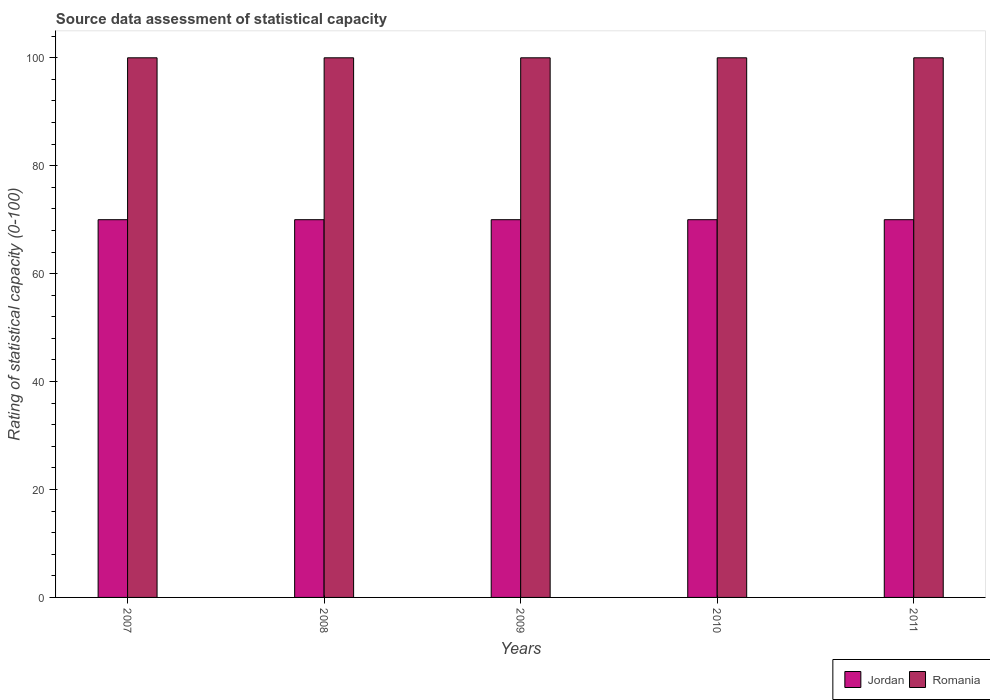How many groups of bars are there?
Make the answer very short. 5. What is the label of the 2nd group of bars from the left?
Keep it short and to the point. 2008. In how many cases, is the number of bars for a given year not equal to the number of legend labels?
Keep it short and to the point. 0. What is the rating of statistical capacity in Jordan in 2008?
Offer a very short reply. 70. Across all years, what is the maximum rating of statistical capacity in Romania?
Provide a succinct answer. 100. Across all years, what is the minimum rating of statistical capacity in Jordan?
Your answer should be compact. 70. In which year was the rating of statistical capacity in Romania maximum?
Provide a succinct answer. 2007. In which year was the rating of statistical capacity in Jordan minimum?
Provide a short and direct response. 2007. What is the total rating of statistical capacity in Jordan in the graph?
Make the answer very short. 350. What is the difference between the rating of statistical capacity in Jordan in 2011 and the rating of statistical capacity in Romania in 2009?
Keep it short and to the point. -30. In the year 2009, what is the difference between the rating of statistical capacity in Jordan and rating of statistical capacity in Romania?
Your answer should be compact. -30. What is the ratio of the rating of statistical capacity in Romania in 2008 to that in 2009?
Make the answer very short. 1. Is the difference between the rating of statistical capacity in Jordan in 2008 and 2010 greater than the difference between the rating of statistical capacity in Romania in 2008 and 2010?
Ensure brevity in your answer.  No. What does the 1st bar from the left in 2007 represents?
Keep it short and to the point. Jordan. What does the 2nd bar from the right in 2009 represents?
Keep it short and to the point. Jordan. How many bars are there?
Provide a succinct answer. 10. How many years are there in the graph?
Provide a succinct answer. 5. What is the difference between two consecutive major ticks on the Y-axis?
Give a very brief answer. 20. Are the values on the major ticks of Y-axis written in scientific E-notation?
Make the answer very short. No. Does the graph contain any zero values?
Ensure brevity in your answer.  No. Does the graph contain grids?
Provide a short and direct response. No. Where does the legend appear in the graph?
Keep it short and to the point. Bottom right. What is the title of the graph?
Your answer should be compact. Source data assessment of statistical capacity. What is the label or title of the X-axis?
Give a very brief answer. Years. What is the label or title of the Y-axis?
Provide a succinct answer. Rating of statistical capacity (0-100). What is the Rating of statistical capacity (0-100) of Romania in 2007?
Make the answer very short. 100. What is the Rating of statistical capacity (0-100) of Jordan in 2008?
Keep it short and to the point. 70. What is the Rating of statistical capacity (0-100) of Jordan in 2009?
Make the answer very short. 70. What is the Rating of statistical capacity (0-100) of Romania in 2011?
Make the answer very short. 100. Across all years, what is the maximum Rating of statistical capacity (0-100) in Jordan?
Provide a succinct answer. 70. Across all years, what is the maximum Rating of statistical capacity (0-100) in Romania?
Provide a short and direct response. 100. What is the total Rating of statistical capacity (0-100) of Jordan in the graph?
Offer a terse response. 350. What is the total Rating of statistical capacity (0-100) of Romania in the graph?
Provide a succinct answer. 500. What is the difference between the Rating of statistical capacity (0-100) of Romania in 2007 and that in 2009?
Offer a terse response. 0. What is the difference between the Rating of statistical capacity (0-100) of Jordan in 2007 and that in 2010?
Provide a succinct answer. 0. What is the difference between the Rating of statistical capacity (0-100) in Jordan in 2007 and that in 2011?
Your answer should be very brief. 0. What is the difference between the Rating of statistical capacity (0-100) of Jordan in 2008 and that in 2009?
Offer a terse response. 0. What is the difference between the Rating of statistical capacity (0-100) in Romania in 2008 and that in 2009?
Provide a succinct answer. 0. What is the difference between the Rating of statistical capacity (0-100) in Romania in 2008 and that in 2010?
Provide a short and direct response. 0. What is the difference between the Rating of statistical capacity (0-100) of Romania in 2008 and that in 2011?
Keep it short and to the point. 0. What is the difference between the Rating of statistical capacity (0-100) of Jordan in 2009 and that in 2010?
Your response must be concise. 0. What is the difference between the Rating of statistical capacity (0-100) of Romania in 2009 and that in 2010?
Your response must be concise. 0. What is the difference between the Rating of statistical capacity (0-100) in Jordan in 2009 and that in 2011?
Provide a short and direct response. 0. What is the difference between the Rating of statistical capacity (0-100) of Jordan in 2010 and that in 2011?
Give a very brief answer. 0. What is the difference between the Rating of statistical capacity (0-100) of Romania in 2010 and that in 2011?
Offer a terse response. 0. What is the difference between the Rating of statistical capacity (0-100) in Jordan in 2007 and the Rating of statistical capacity (0-100) in Romania in 2010?
Your answer should be compact. -30. What is the difference between the Rating of statistical capacity (0-100) of Jordan in 2008 and the Rating of statistical capacity (0-100) of Romania in 2009?
Make the answer very short. -30. What is the average Rating of statistical capacity (0-100) of Romania per year?
Provide a succinct answer. 100. In the year 2008, what is the difference between the Rating of statistical capacity (0-100) of Jordan and Rating of statistical capacity (0-100) of Romania?
Make the answer very short. -30. In the year 2010, what is the difference between the Rating of statistical capacity (0-100) in Jordan and Rating of statistical capacity (0-100) in Romania?
Ensure brevity in your answer.  -30. In the year 2011, what is the difference between the Rating of statistical capacity (0-100) in Jordan and Rating of statistical capacity (0-100) in Romania?
Give a very brief answer. -30. What is the ratio of the Rating of statistical capacity (0-100) of Romania in 2007 to that in 2008?
Offer a terse response. 1. What is the ratio of the Rating of statistical capacity (0-100) in Jordan in 2007 to that in 2009?
Make the answer very short. 1. What is the ratio of the Rating of statistical capacity (0-100) of Romania in 2007 to that in 2009?
Offer a terse response. 1. What is the ratio of the Rating of statistical capacity (0-100) of Jordan in 2008 to that in 2009?
Provide a succinct answer. 1. What is the ratio of the Rating of statistical capacity (0-100) in Jordan in 2008 to that in 2010?
Your answer should be very brief. 1. What is the ratio of the Rating of statistical capacity (0-100) of Romania in 2008 to that in 2010?
Your answer should be very brief. 1. What is the ratio of the Rating of statistical capacity (0-100) in Jordan in 2009 to that in 2010?
Your answer should be very brief. 1. What is the ratio of the Rating of statistical capacity (0-100) in Jordan in 2010 to that in 2011?
Offer a very short reply. 1. What is the ratio of the Rating of statistical capacity (0-100) in Romania in 2010 to that in 2011?
Your answer should be compact. 1. What is the difference between the highest and the second highest Rating of statistical capacity (0-100) in Jordan?
Your answer should be compact. 0. What is the difference between the highest and the second highest Rating of statistical capacity (0-100) in Romania?
Keep it short and to the point. 0. What is the difference between the highest and the lowest Rating of statistical capacity (0-100) in Romania?
Keep it short and to the point. 0. 